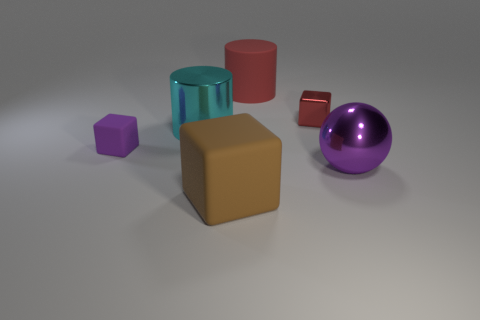Add 2 tiny red cylinders. How many objects exist? 8 Add 1 big purple metal things. How many big purple metal things exist? 2 Subtract 0 brown balls. How many objects are left? 6 Subtract all cylinders. How many objects are left? 4 Subtract all red shiny cylinders. Subtract all tiny purple rubber cubes. How many objects are left? 5 Add 3 brown blocks. How many brown blocks are left? 4 